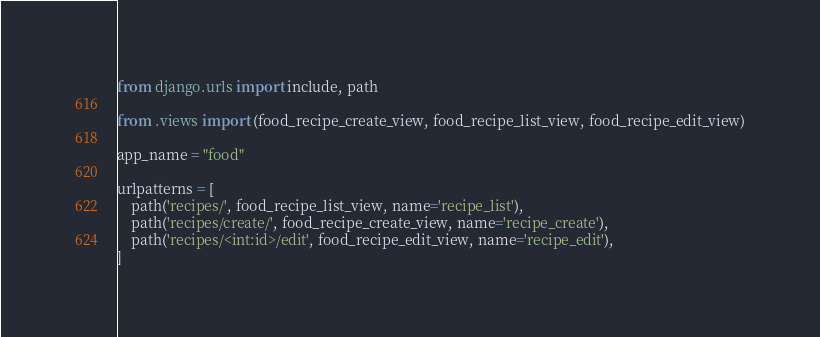<code> <loc_0><loc_0><loc_500><loc_500><_Python_>from django.urls import include, path

from .views import (food_recipe_create_view, food_recipe_list_view, food_recipe_edit_view)

app_name = "food"

urlpatterns = [
    path('recipes/', food_recipe_list_view, name='recipe_list'),
    path('recipes/create/', food_recipe_create_view, name='recipe_create'),
    path('recipes/<int:id>/edit', food_recipe_edit_view, name='recipe_edit'),
]</code> 